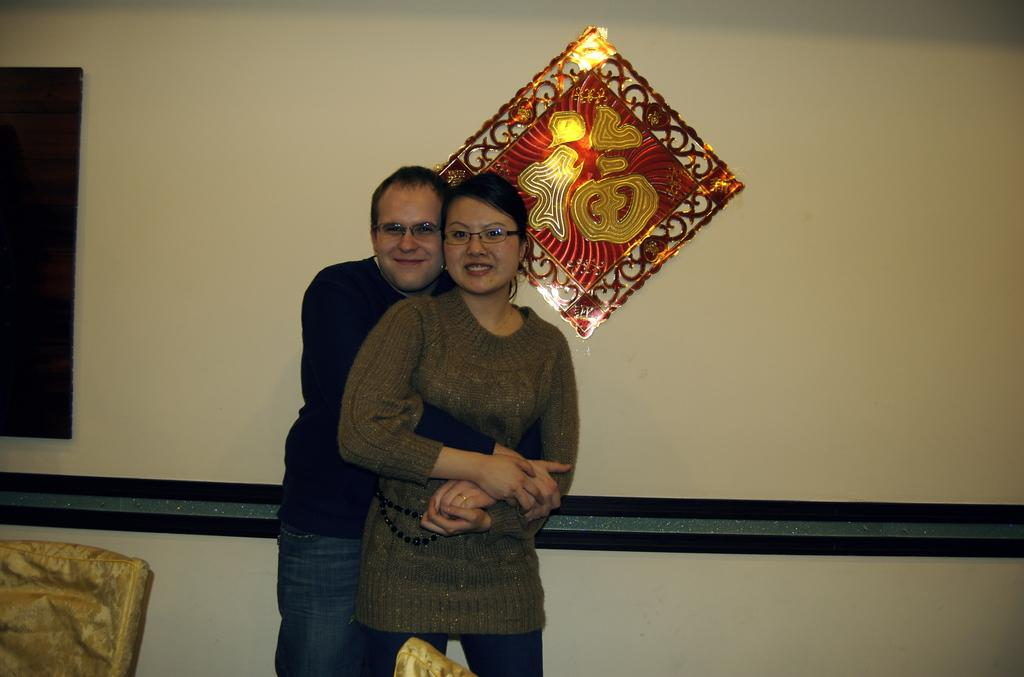How many people can be seen in the image? There are a few people in the image. What is visible in the background of the image? There is a wall with some objects in the background. Can you describe the object in the bottom left corner of the image? There is an object on the bottom left corner of the image. What is the location of the other object in the image? There is an object at the bottom of the image. What type of force is causing the earthquake in the image? There is no earthquake present in the image. Can you tell me where the scissors are located in the image? There is no mention of scissors in the provided facts, so we cannot determine their location in the image. 